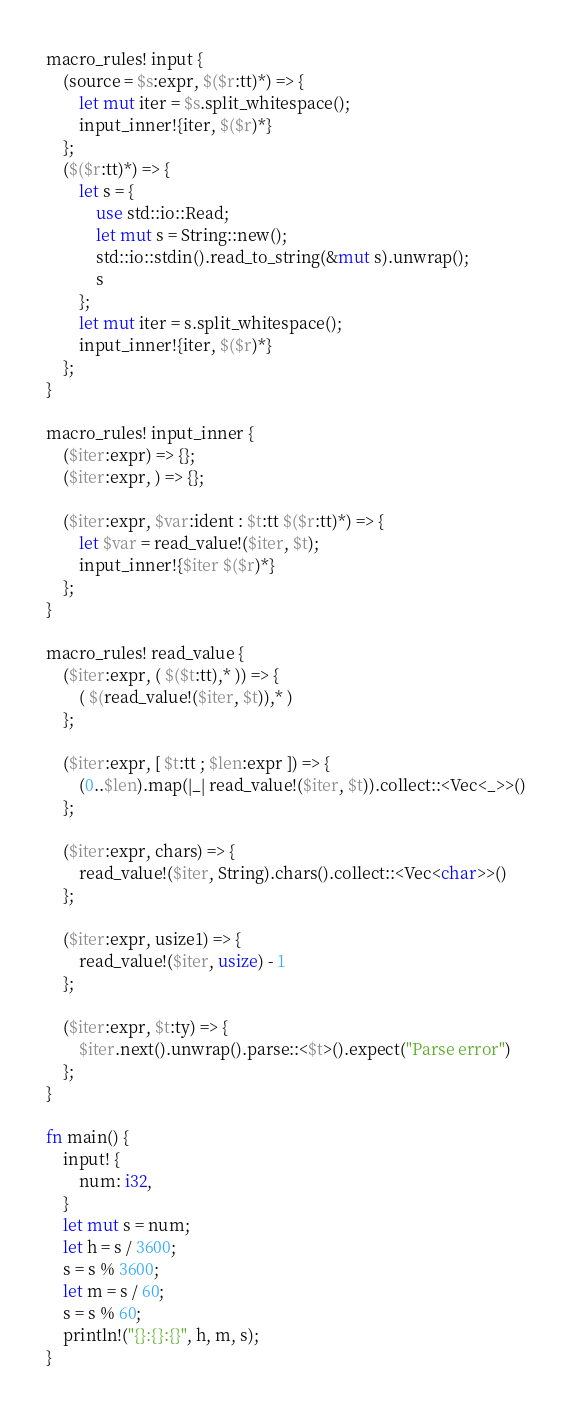<code> <loc_0><loc_0><loc_500><loc_500><_Rust_>macro_rules! input {
    (source = $s:expr, $($r:tt)*) => {
        let mut iter = $s.split_whitespace();
        input_inner!{iter, $($r)*}
    };
    ($($r:tt)*) => {
        let s = {
            use std::io::Read;
            let mut s = String::new();
            std::io::stdin().read_to_string(&mut s).unwrap();
            s
        };
        let mut iter = s.split_whitespace();
        input_inner!{iter, $($r)*}
    };
}

macro_rules! input_inner {
    ($iter:expr) => {};
    ($iter:expr, ) => {};
 
    ($iter:expr, $var:ident : $t:tt $($r:tt)*) => {
        let $var = read_value!($iter, $t);
        input_inner!{$iter $($r)*}
    };
}

macro_rules! read_value {
    ($iter:expr, ( $($t:tt),* )) => {
        ( $(read_value!($iter, $t)),* )
    };
 
    ($iter:expr, [ $t:tt ; $len:expr ]) => {
        (0..$len).map(|_| read_value!($iter, $t)).collect::<Vec<_>>()
    };
 
    ($iter:expr, chars) => {
        read_value!($iter, String).chars().collect::<Vec<char>>()
    };
 
    ($iter:expr, usize1) => {
        read_value!($iter, usize) - 1
    };
 
    ($iter:expr, $t:ty) => {
        $iter.next().unwrap().parse::<$t>().expect("Parse error")
    };
}

fn main() {
    input! {
        num: i32,
    }
    let mut s = num;
    let h = s / 3600;
    s = s % 3600;
    let m = s / 60;
    s = s % 60;
    println!("{}:{}:{}", h, m, s);
}
</code> 